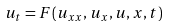<formula> <loc_0><loc_0><loc_500><loc_500>u _ { t } = F ( u _ { x x } , u _ { x } , u , x , t )</formula> 